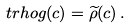<formula> <loc_0><loc_0><loc_500><loc_500>\ t r h o g ( c ) = \widetilde { \rho } ( c ) \, .</formula> 